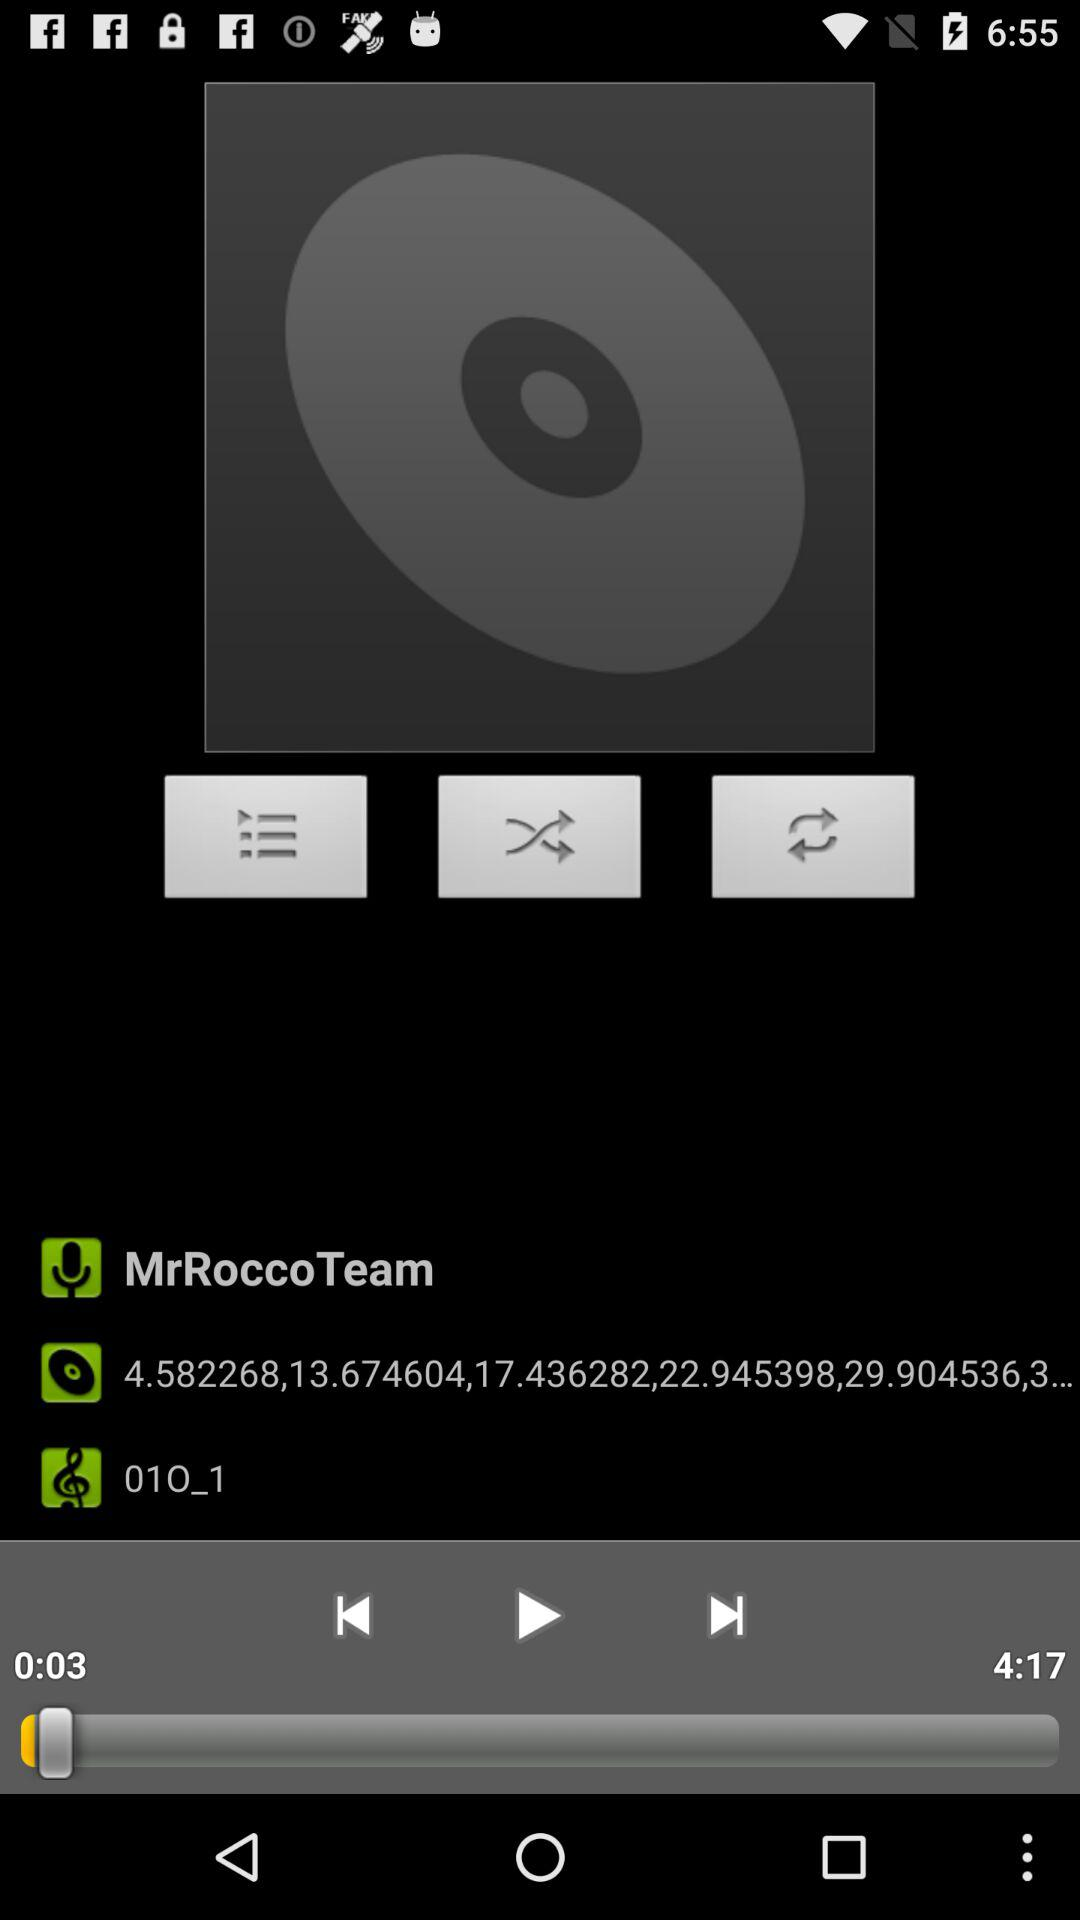What is the duration of the audio that was last played? The duration of the audio that was last played is 4 minutes 17 seconds. 